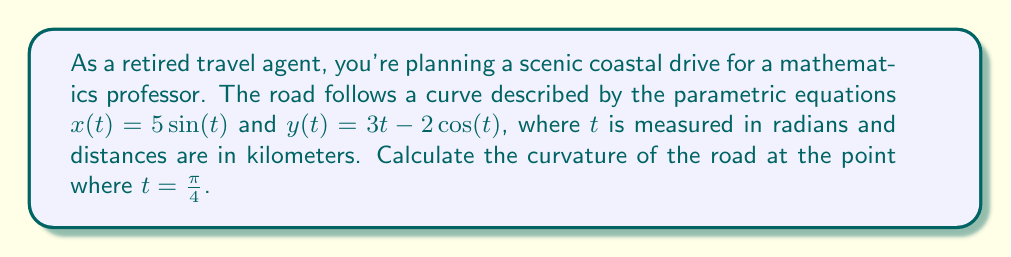Show me your answer to this math problem. To find the curvature of the road at a specific point, we'll follow these steps:

1) Recall the formula for curvature $K$ of a curve given by parametric equations:

   $$K = \frac{|x'y'' - y'x''|}{(x'^2 + y'^2)^{3/2}}$$

2) First, we need to find $x'(t)$, $y'(t)$, $x''(t)$, and $y''(t)$:

   $x'(t) = 5\cos(t)$
   $y'(t) = 3 + 2\sin(t)$
   $x''(t) = -5\sin(t)$
   $y''(t) = 2\cos(t)$

3) Now, let's evaluate these at $t = \frac{\pi}{4}$:

   $x'(\frac{\pi}{4}) = 5\cos(\frac{\pi}{4}) = \frac{5\sqrt{2}}{2}$
   $y'(\frac{\pi}{4}) = 3 + 2\sin(\frac{\pi}{4}) = 3 + \sqrt{2}$
   $x''(\frac{\pi}{4}) = -5\sin(\frac{\pi}{4}) = -\frac{5\sqrt{2}}{2}$
   $y''(\frac{\pi}{4}) = 2\cos(\frac{\pi}{4}) = \sqrt{2}$

4) Now we can calculate the numerator and denominator of the curvature formula:

   Numerator: $|x'y'' - y'x''| = |\frac{5\sqrt{2}}{2} \cdot \sqrt{2} - (3 + \sqrt{2}) \cdot (-\frac{5\sqrt{2}}{2})|$
                                $= |5 + \frac{15\sqrt{2}}{2} + \frac{5}{2}|$
                                $= 5 + \frac{15\sqrt{2}}{2} + \frac{5}{2}$
                                $= \frac{25 + 15\sqrt{2}}{2}$

   Denominator: $(x'^2 + y'^2)^{3/2} = ((\frac{5\sqrt{2}}{2})^2 + (3 + \sqrt{2})^2)^{3/2}$
                                     $= (25/2 + 9 + 6\sqrt{2} + 2)^{3/2}$
                                     $= (\frac{35 + 12\sqrt{2}}{2})^{3/2}$

5) Therefore, the curvature is:

   $$K = \frac{\frac{25 + 15\sqrt{2}}{2}}{(\frac{35 + 12\sqrt{2}}{2})^{3/2}}$$

6) This can be simplified slightly to:

   $$K = \frac{25 + 15\sqrt{2}}{(35 + 12\sqrt{2})^{3/2}} \cdot \sqrt{2}$$
Answer: The curvature of the coastal road at $t = \frac{\pi}{4}$ is $\frac{25 + 15\sqrt{2}}{(35 + 12\sqrt{2})^{3/2}} \cdot \sqrt{2}$ km$^{-1}$. 